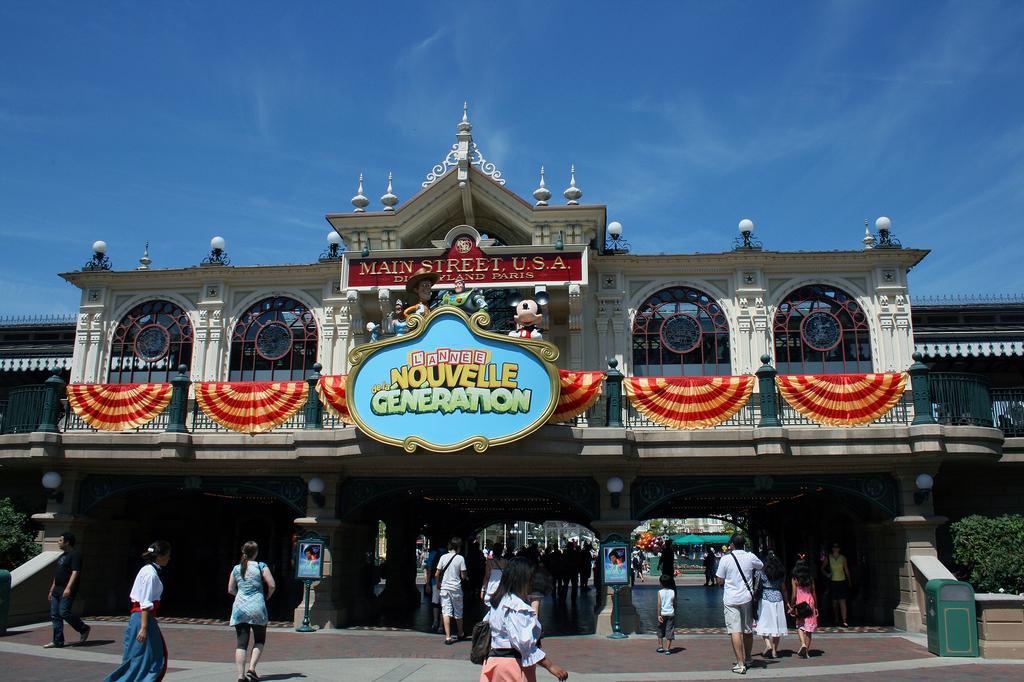Can you describe this image briefly? In this image in the middle there is a building, window, poster, toys, cloth and text. At the bottom there are many people walking. On the right there is a man he wear shirt and trouser. On the left there is a woman she is walking. At the top there is a sky. On the right there is a plant. 